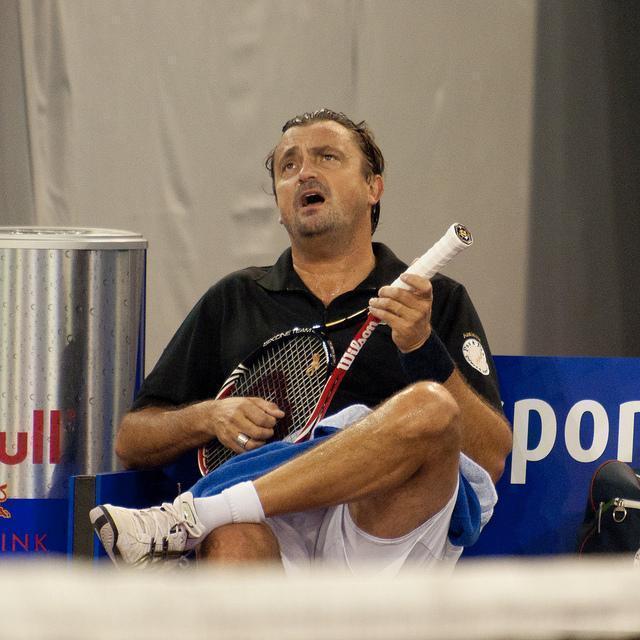He is pretending the tennis racket is what?
Choose the right answer from the provided options to respond to the question.
Options: Guitar, violin, cello, flute. Guitar. 